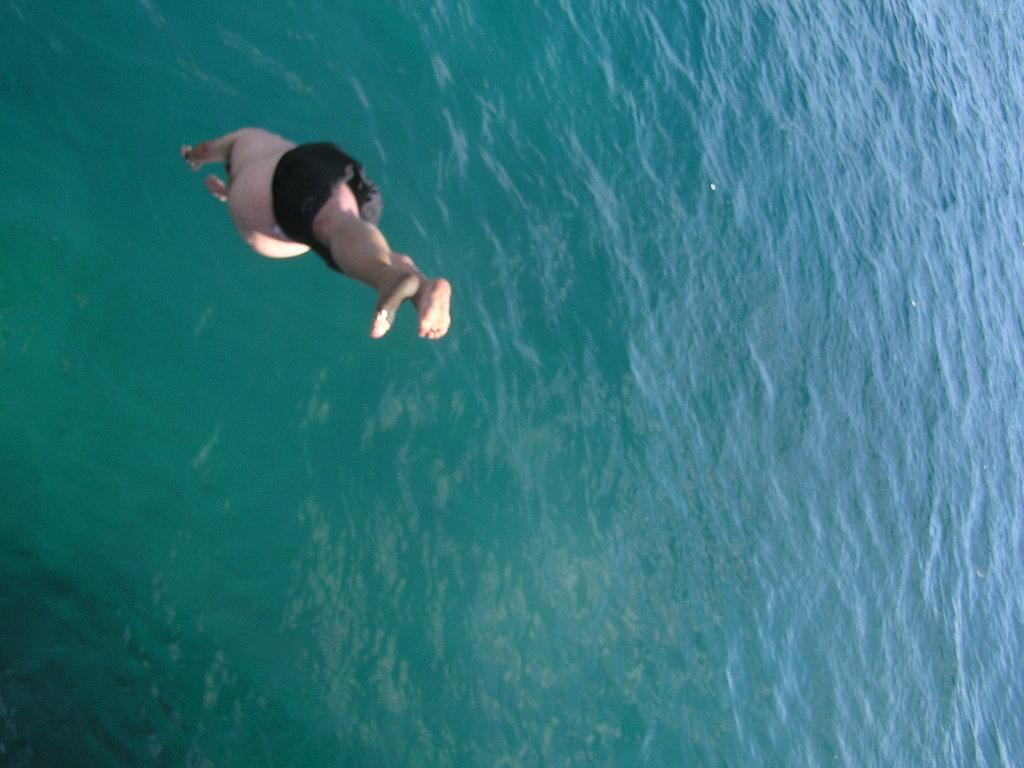Who is the main subject in the image? There is a man in the image. What is the man doing in the image? The man is diving in the water. What time does the clock show in the image? There is no clock present in the image. How many cows are visible in the image? There are no cows visible in the image; it features a man diving in the water. 